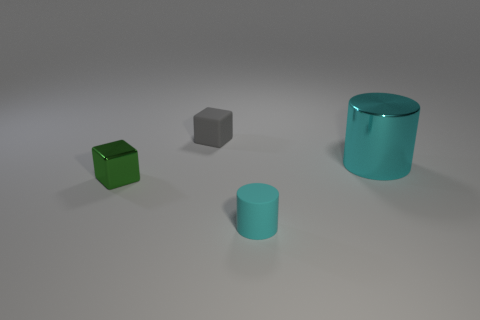Are there any other things that have the same size as the cyan shiny thing?
Offer a very short reply. No. What number of matte objects have the same color as the large cylinder?
Offer a terse response. 1. What number of objects are either purple matte balls or gray blocks?
Provide a short and direct response. 1. There is a green object that is the same size as the cyan rubber object; what is its shape?
Your answer should be very brief. Cube. What number of objects are both in front of the small metal thing and left of the small gray matte thing?
Your answer should be very brief. 0. What material is the small block in front of the small gray rubber cube?
Give a very brief answer. Metal. What is the size of the cyan cylinder that is made of the same material as the gray block?
Your response must be concise. Small. Is the size of the metal thing to the left of the tiny cylinder the same as the cyan object that is in front of the green cube?
Provide a short and direct response. Yes. What is the material of the cyan cylinder that is the same size as the metallic block?
Make the answer very short. Rubber. What is the thing that is to the right of the gray rubber thing and behind the green cube made of?
Your response must be concise. Metal. 